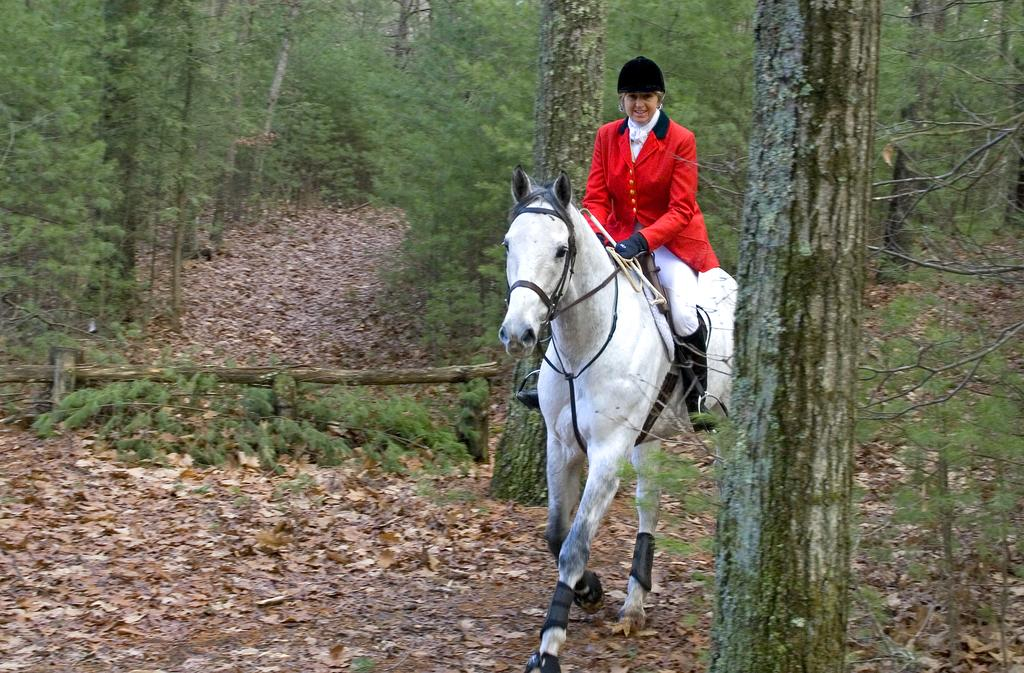Who or what is the main subject in the image? There is a person in the image. What is the person doing in the image? The person is sitting on a horse and riding it. What can be seen in the background of the image? There are trees and dry leaves in the background of the image. What type of form does the rainstorm take in the image? There is no rainstorm present in the image. Can you describe the facial expression of the person on the horse? The image does not show the person's face, so it is not possible to describe their facial expression. 